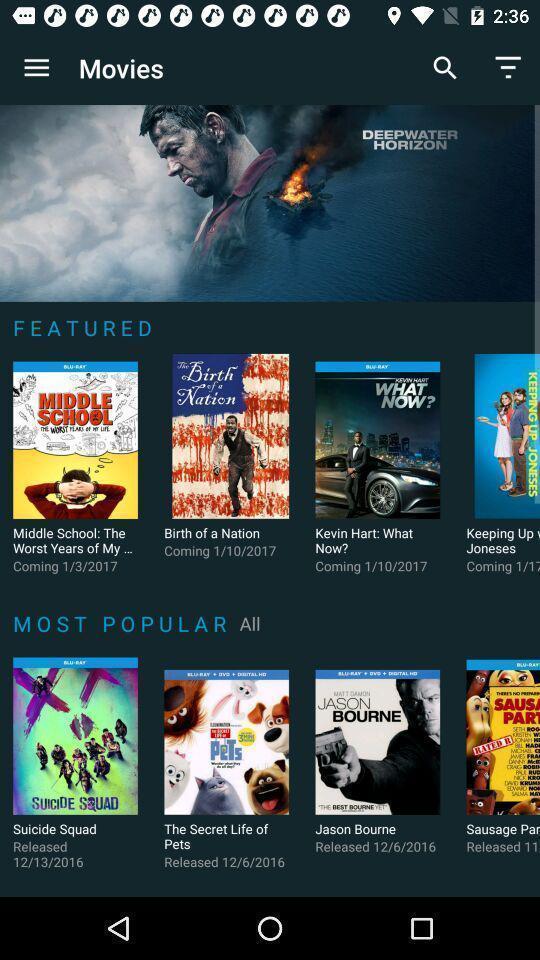Explain the elements present in this screenshot. Screen shows number of movies in a movie app. 